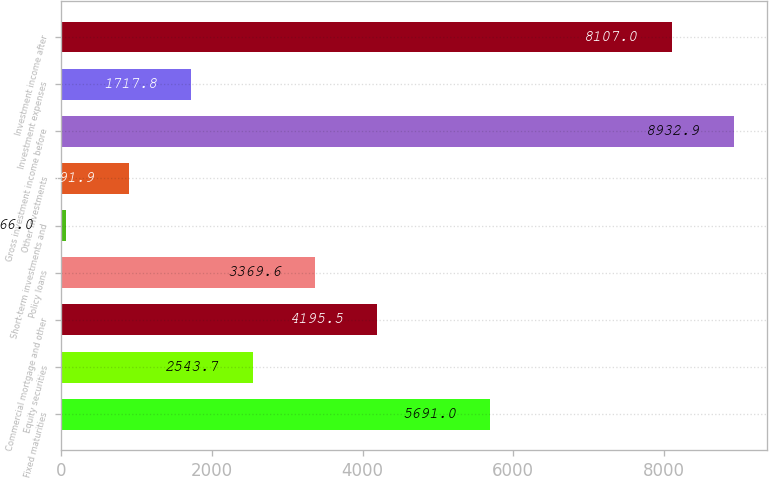Convert chart. <chart><loc_0><loc_0><loc_500><loc_500><bar_chart><fcel>Fixed maturities<fcel>Equity securities<fcel>Commercial mortgage and other<fcel>Policy loans<fcel>Short-term investments and<fcel>Other investments<fcel>Gross investment income before<fcel>Investment expenses<fcel>Investment income after<nl><fcel>5691<fcel>2543.7<fcel>4195.5<fcel>3369.6<fcel>66<fcel>891.9<fcel>8932.9<fcel>1717.8<fcel>8107<nl></chart> 